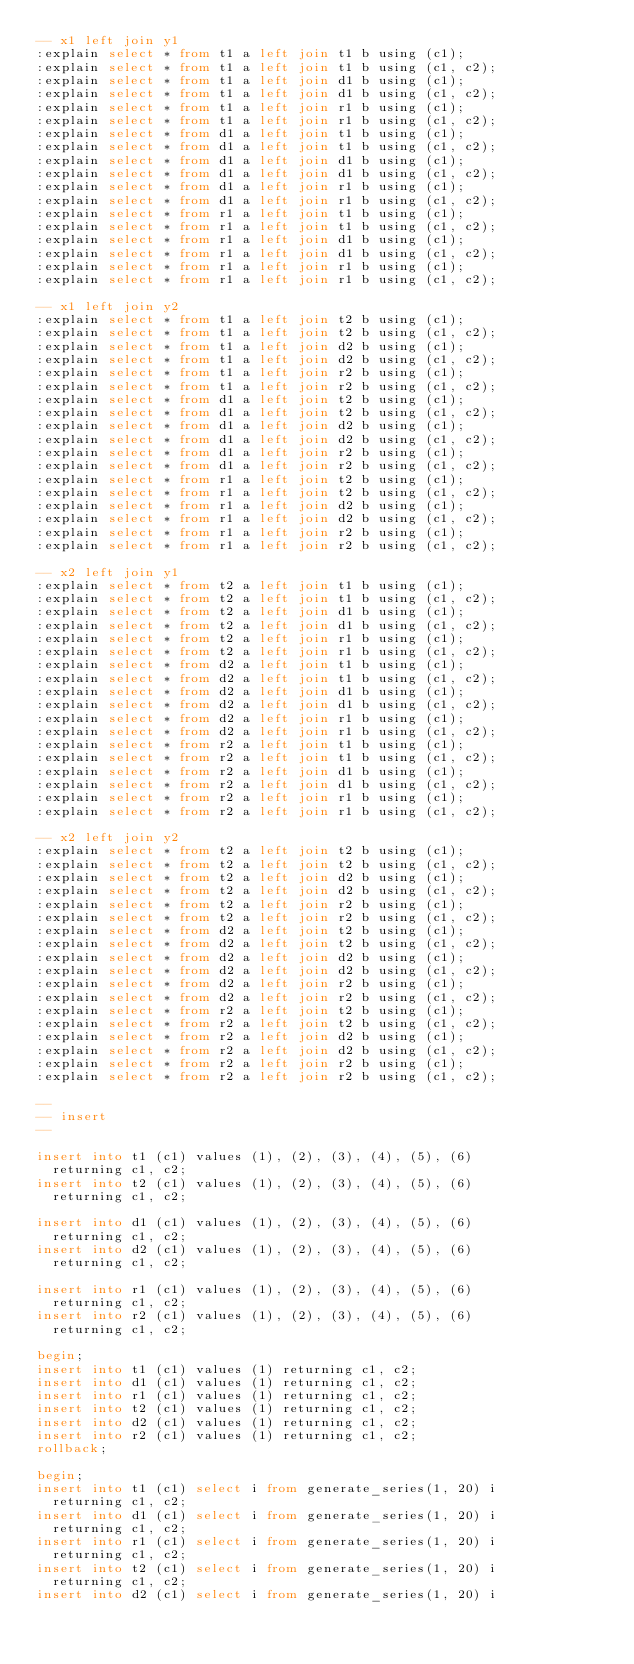<code> <loc_0><loc_0><loc_500><loc_500><_SQL_>-- x1 left join y1
:explain select * from t1 a left join t1 b using (c1);
:explain select * from t1 a left join t1 b using (c1, c2);
:explain select * from t1 a left join d1 b using (c1);
:explain select * from t1 a left join d1 b using (c1, c2);
:explain select * from t1 a left join r1 b using (c1);
:explain select * from t1 a left join r1 b using (c1, c2);
:explain select * from d1 a left join t1 b using (c1);
:explain select * from d1 a left join t1 b using (c1, c2);
:explain select * from d1 a left join d1 b using (c1);
:explain select * from d1 a left join d1 b using (c1, c2);
:explain select * from d1 a left join r1 b using (c1);
:explain select * from d1 a left join r1 b using (c1, c2);
:explain select * from r1 a left join t1 b using (c1);
:explain select * from r1 a left join t1 b using (c1, c2);
:explain select * from r1 a left join d1 b using (c1);
:explain select * from r1 a left join d1 b using (c1, c2);
:explain select * from r1 a left join r1 b using (c1);
:explain select * from r1 a left join r1 b using (c1, c2);

-- x1 left join y2
:explain select * from t1 a left join t2 b using (c1);
:explain select * from t1 a left join t2 b using (c1, c2);
:explain select * from t1 a left join d2 b using (c1);
:explain select * from t1 a left join d2 b using (c1, c2);
:explain select * from t1 a left join r2 b using (c1);
:explain select * from t1 a left join r2 b using (c1, c2);
:explain select * from d1 a left join t2 b using (c1);
:explain select * from d1 a left join t2 b using (c1, c2);
:explain select * from d1 a left join d2 b using (c1);
:explain select * from d1 a left join d2 b using (c1, c2);
:explain select * from d1 a left join r2 b using (c1);
:explain select * from d1 a left join r2 b using (c1, c2);
:explain select * from r1 a left join t2 b using (c1);
:explain select * from r1 a left join t2 b using (c1, c2);
:explain select * from r1 a left join d2 b using (c1);
:explain select * from r1 a left join d2 b using (c1, c2);
:explain select * from r1 a left join r2 b using (c1);
:explain select * from r1 a left join r2 b using (c1, c2);

-- x2 left join y1
:explain select * from t2 a left join t1 b using (c1);
:explain select * from t2 a left join t1 b using (c1, c2);
:explain select * from t2 a left join d1 b using (c1);
:explain select * from t2 a left join d1 b using (c1, c2);
:explain select * from t2 a left join r1 b using (c1);
:explain select * from t2 a left join r1 b using (c1, c2);
:explain select * from d2 a left join t1 b using (c1);
:explain select * from d2 a left join t1 b using (c1, c2);
:explain select * from d2 a left join d1 b using (c1);
:explain select * from d2 a left join d1 b using (c1, c2);
:explain select * from d2 a left join r1 b using (c1);
:explain select * from d2 a left join r1 b using (c1, c2);
:explain select * from r2 a left join t1 b using (c1);
:explain select * from r2 a left join t1 b using (c1, c2);
:explain select * from r2 a left join d1 b using (c1);
:explain select * from r2 a left join d1 b using (c1, c2);
:explain select * from r2 a left join r1 b using (c1);
:explain select * from r2 a left join r1 b using (c1, c2);

-- x2 left join y2
:explain select * from t2 a left join t2 b using (c1);
:explain select * from t2 a left join t2 b using (c1, c2);
:explain select * from t2 a left join d2 b using (c1);
:explain select * from t2 a left join d2 b using (c1, c2);
:explain select * from t2 a left join r2 b using (c1);
:explain select * from t2 a left join r2 b using (c1, c2);
:explain select * from d2 a left join t2 b using (c1);
:explain select * from d2 a left join t2 b using (c1, c2);
:explain select * from d2 a left join d2 b using (c1);
:explain select * from d2 a left join d2 b using (c1, c2);
:explain select * from d2 a left join r2 b using (c1);
:explain select * from d2 a left join r2 b using (c1, c2);
:explain select * from r2 a left join t2 b using (c1);
:explain select * from r2 a left join t2 b using (c1, c2);
:explain select * from r2 a left join d2 b using (c1);
:explain select * from r2 a left join d2 b using (c1, c2);
:explain select * from r2 a left join r2 b using (c1);
:explain select * from r2 a left join r2 b using (c1, c2);

--
-- insert
--

insert into t1 (c1) values (1), (2), (3), (4), (5), (6)
	returning c1, c2;
insert into t2 (c1) values (1), (2), (3), (4), (5), (6)
	returning c1, c2;

insert into d1 (c1) values (1), (2), (3), (4), (5), (6)
	returning c1, c2;
insert into d2 (c1) values (1), (2), (3), (4), (5), (6)
	returning c1, c2;

insert into r1 (c1) values (1), (2), (3), (4), (5), (6)
	returning c1, c2;
insert into r2 (c1) values (1), (2), (3), (4), (5), (6)
	returning c1, c2;

begin;
insert into t1 (c1) values (1) returning c1, c2;
insert into d1 (c1) values (1) returning c1, c2;
insert into r1 (c1) values (1) returning c1, c2;
insert into t2 (c1) values (1) returning c1, c2;
insert into d2 (c1) values (1) returning c1, c2;
insert into r2 (c1) values (1) returning c1, c2;
rollback;

begin;
insert into t1 (c1) select i from generate_series(1, 20) i
	returning c1, c2;
insert into d1 (c1) select i from generate_series(1, 20) i
	returning c1, c2;
insert into r1 (c1) select i from generate_series(1, 20) i
	returning c1, c2;
insert into t2 (c1) select i from generate_series(1, 20) i
	returning c1, c2;
insert into d2 (c1) select i from generate_series(1, 20) i</code> 